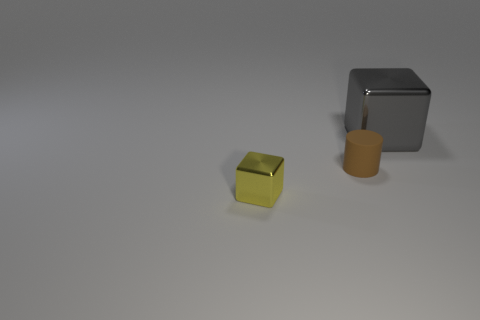Add 2 rubber cylinders. How many objects exist? 5 Subtract all cylinders. How many objects are left? 2 Add 1 big yellow balls. How many big yellow balls exist? 1 Subtract 0 brown spheres. How many objects are left? 3 Subtract all large blue cylinders. Subtract all small yellow blocks. How many objects are left? 2 Add 3 small yellow metallic things. How many small yellow metallic things are left? 4 